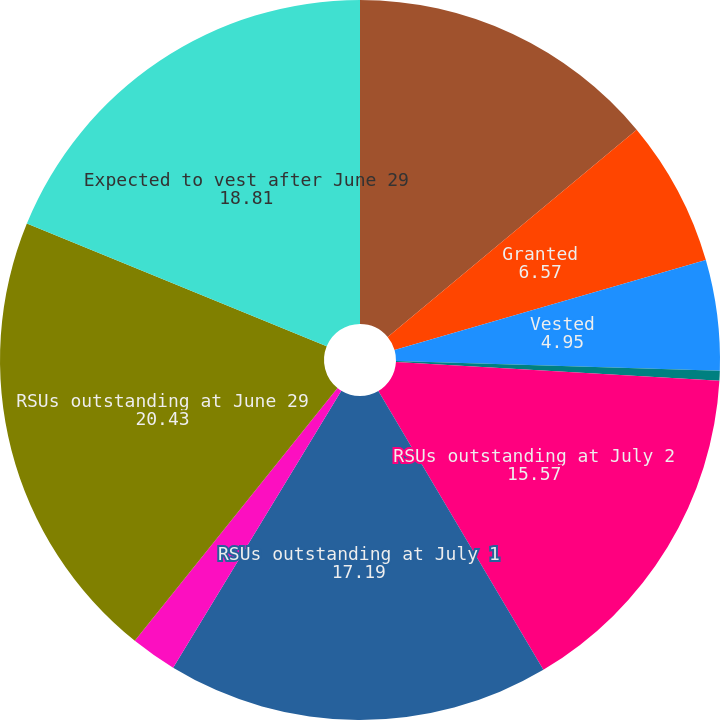Convert chart. <chart><loc_0><loc_0><loc_500><loc_500><pie_chart><fcel>RSUs outstanding at July 3<fcel>Granted<fcel>Vested<fcel>Canceled or expired<fcel>RSUs outstanding at July 2<fcel>RSUs outstanding at July 1<fcel>Assumed<fcel>RSUs outstanding at June 29<fcel>Expected to vest after June 29<nl><fcel>13.95%<fcel>6.57%<fcel>4.95%<fcel>0.45%<fcel>15.57%<fcel>17.19%<fcel>2.07%<fcel>20.43%<fcel>18.81%<nl></chart> 